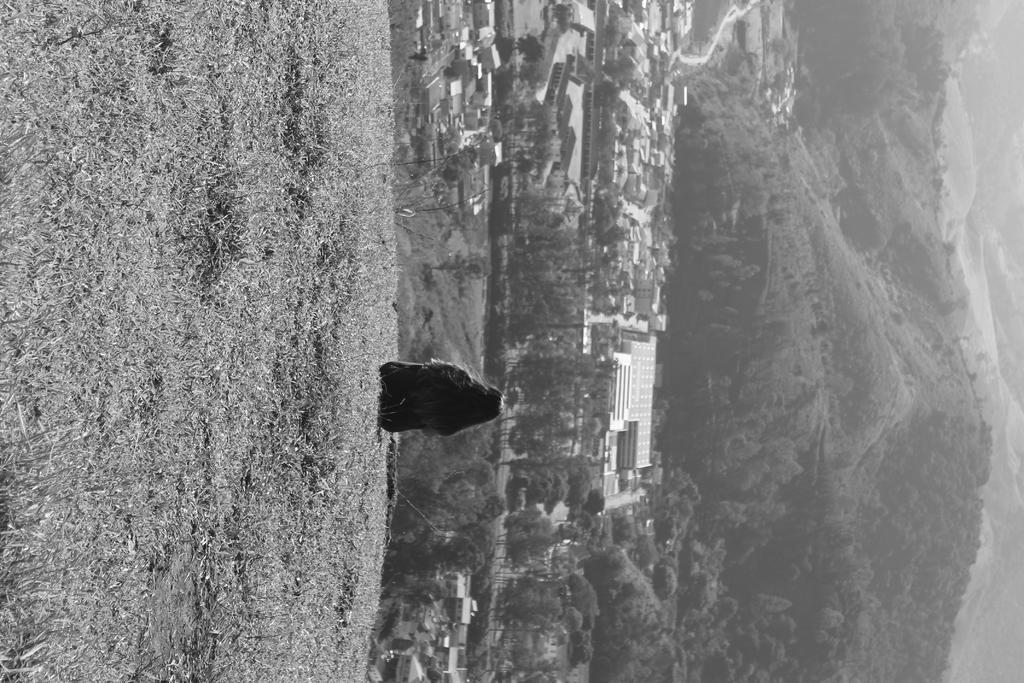Describe this image in one or two sentences. In this image there is a small girl sitting on the grass lawn. Behind there are some houses and mountains. Above there is a sky with clouds. 